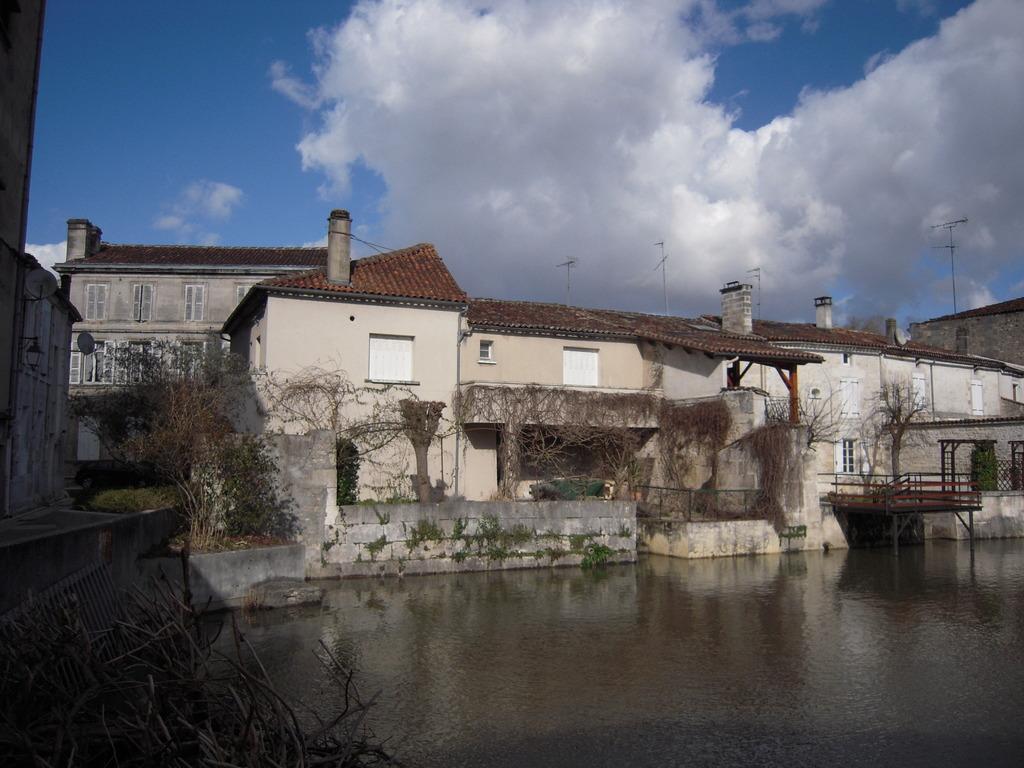In one or two sentences, can you explain what this image depicts? There is water. There are trees and buildings with windows. Also there is a deck with poles. On the left side there is a grille. In the background there is sky with clouds. 